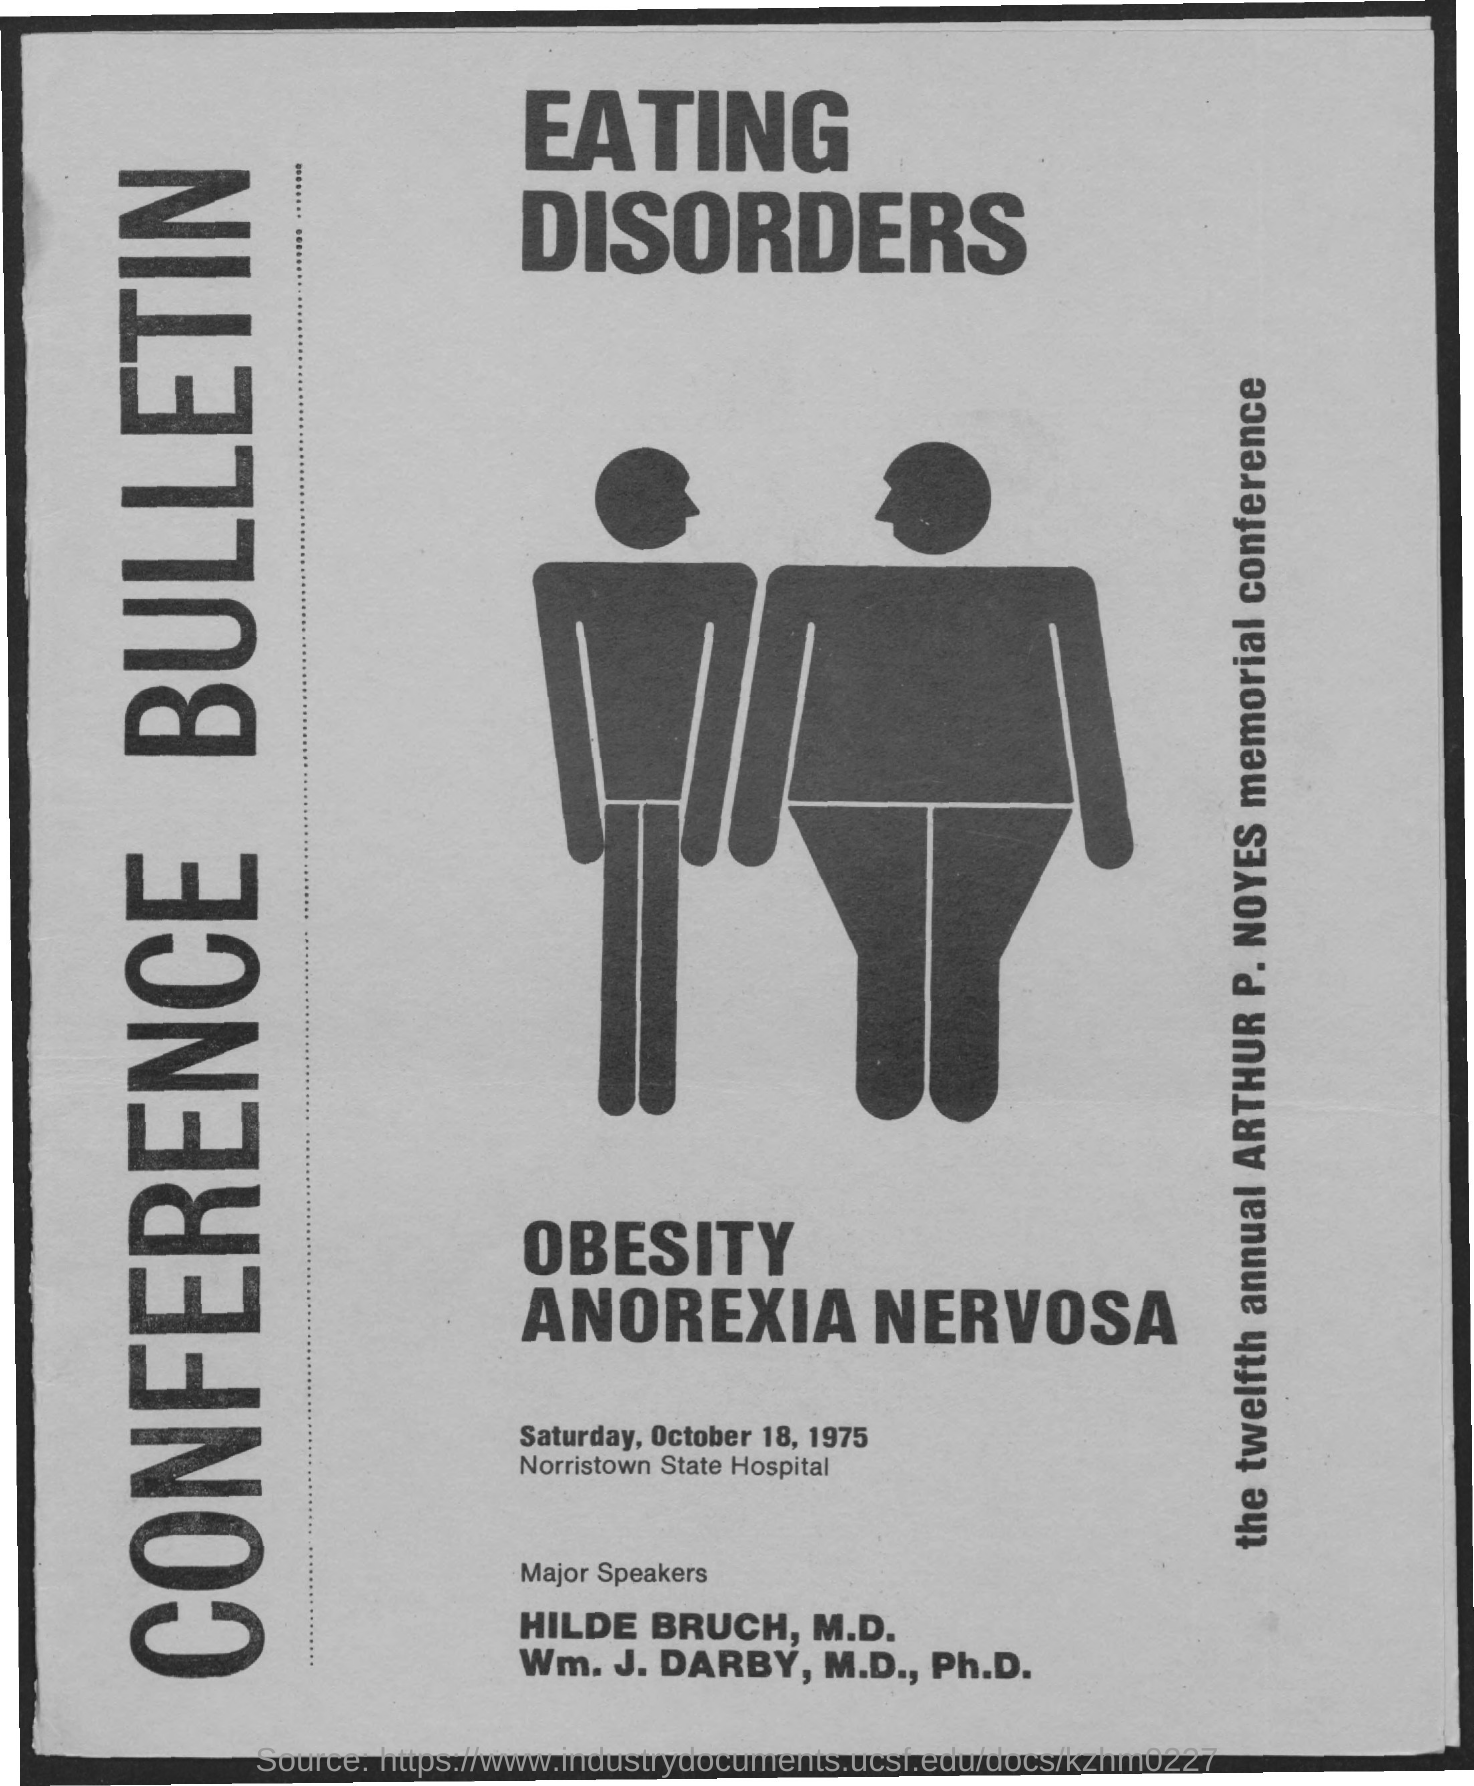Indicate a few pertinent items in this graphic. The conference is scheduled for Saturday, October 18, 1975. Norristown State Hospital is the location of the conference. 